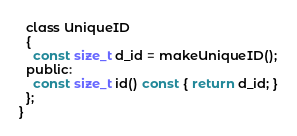Convert code to text. <code><loc_0><loc_0><loc_500><loc_500><_C_>
  class UniqueID
  {
    const size_t d_id = makeUniqueID();
  public:
    const size_t id() const { return d_id; }
  };
}</code> 